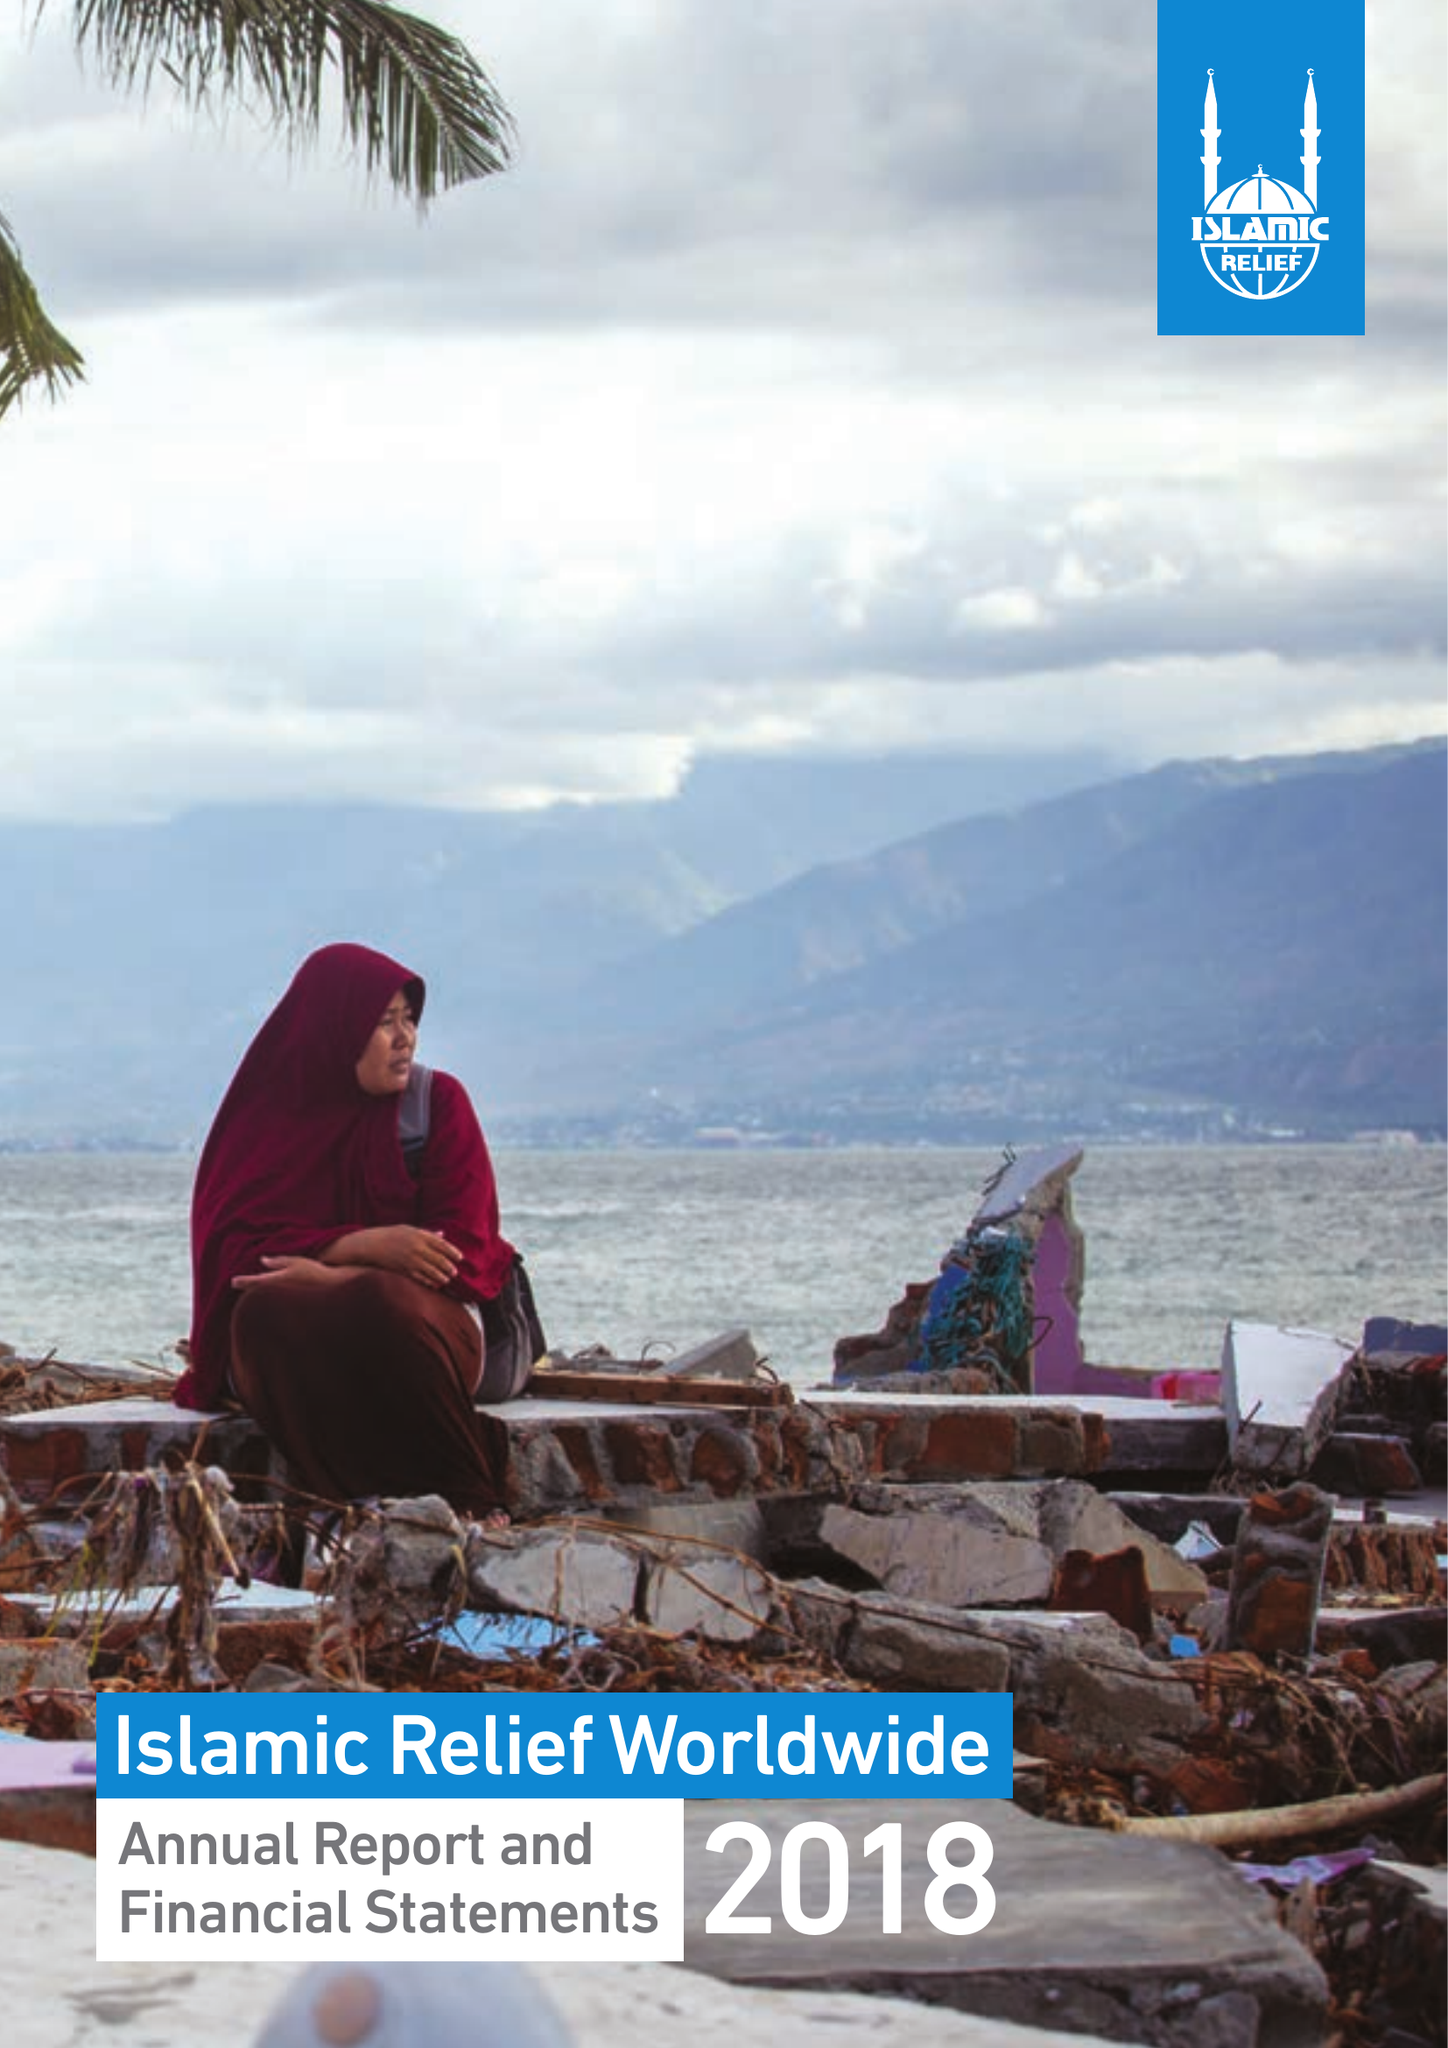What is the value for the charity_number?
Answer the question using a single word or phrase. 328158 